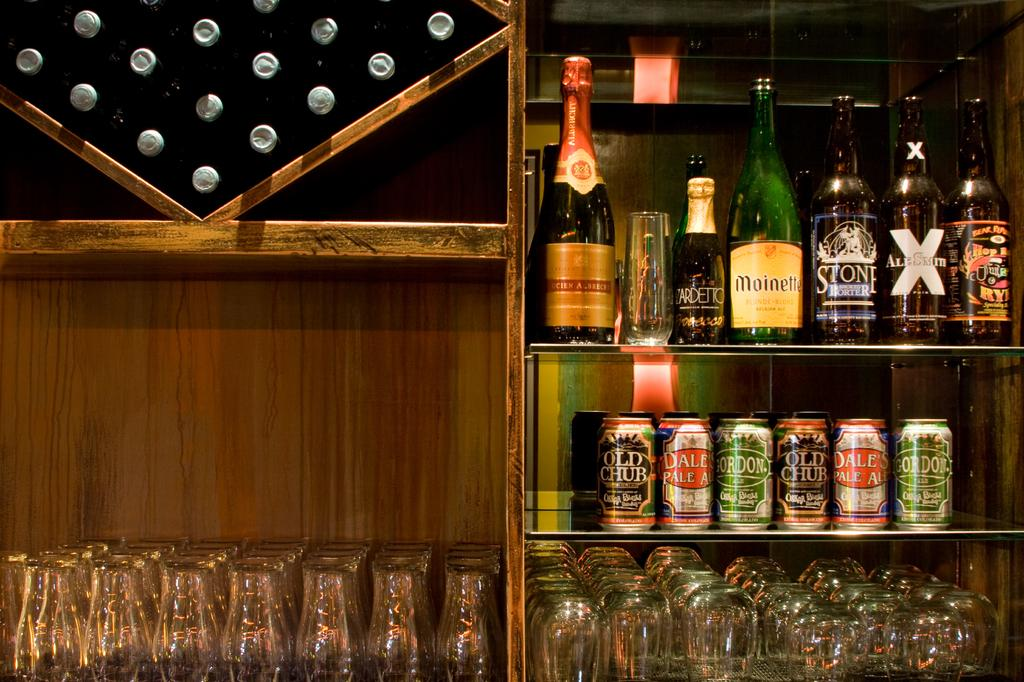What is the main object in the image? There is a rack in the image. What items are stored on the rack? There are wine bottles, tins, and glasses on the rack. How do the pigs interact with the wine bottles on the rack? There are no pigs present in the image, so they cannot interact with the wine bottles on the rack. 